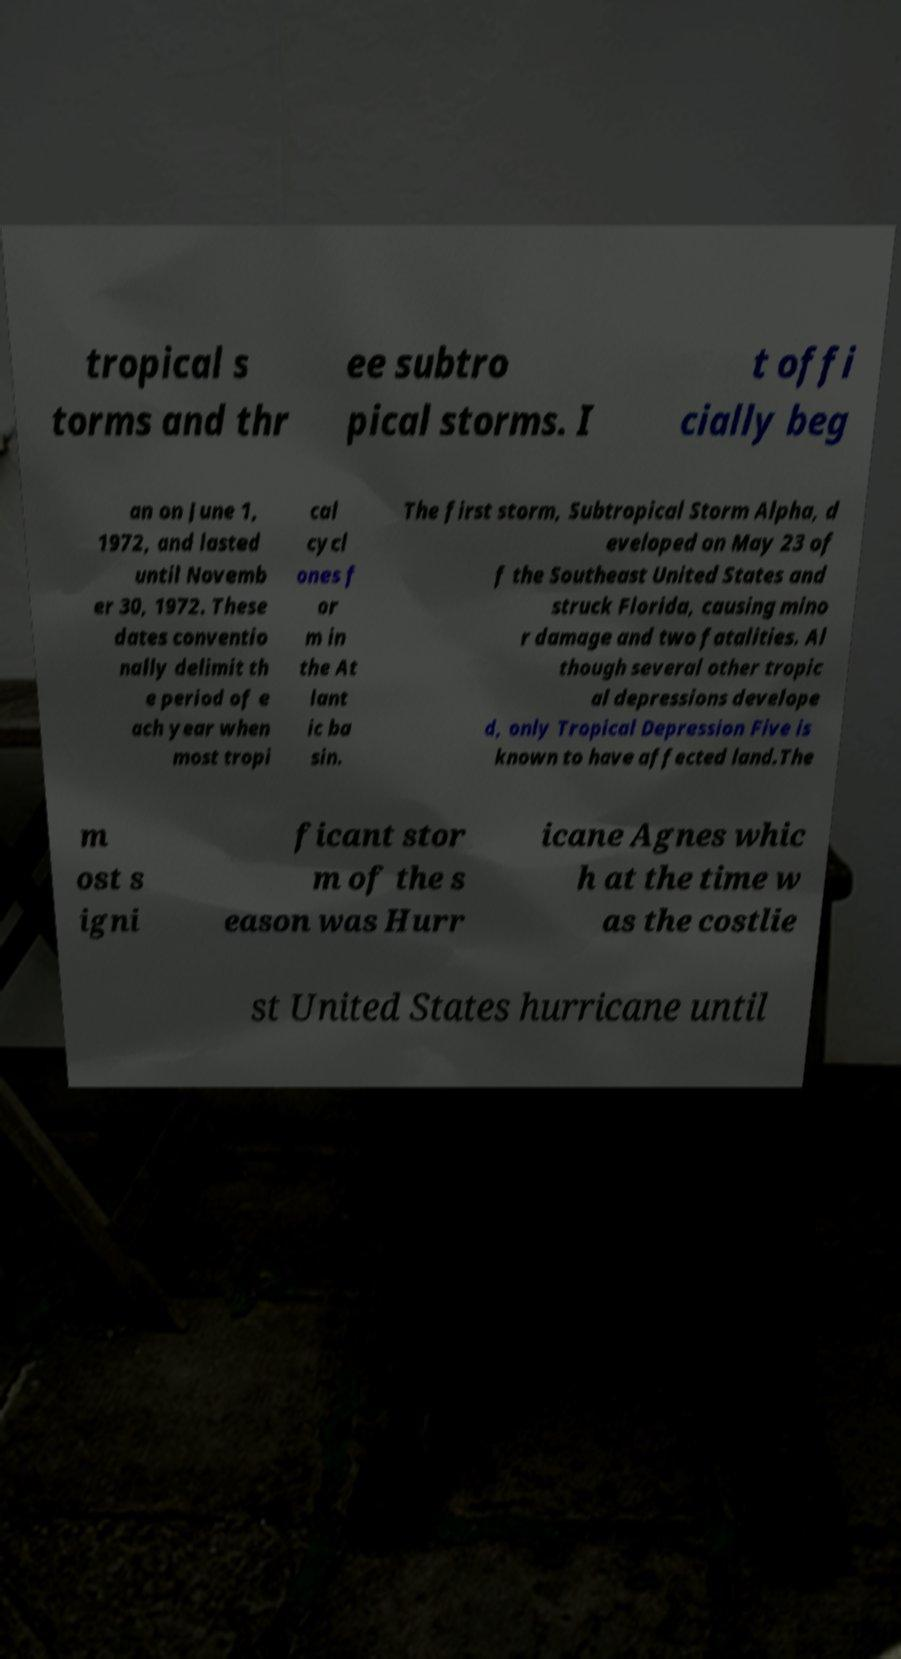Can you read and provide the text displayed in the image?This photo seems to have some interesting text. Can you extract and type it out for me? tropical s torms and thr ee subtro pical storms. I t offi cially beg an on June 1, 1972, and lasted until Novemb er 30, 1972. These dates conventio nally delimit th e period of e ach year when most tropi cal cycl ones f or m in the At lant ic ba sin. The first storm, Subtropical Storm Alpha, d eveloped on May 23 of f the Southeast United States and struck Florida, causing mino r damage and two fatalities. Al though several other tropic al depressions develope d, only Tropical Depression Five is known to have affected land.The m ost s igni ficant stor m of the s eason was Hurr icane Agnes whic h at the time w as the costlie st United States hurricane until 